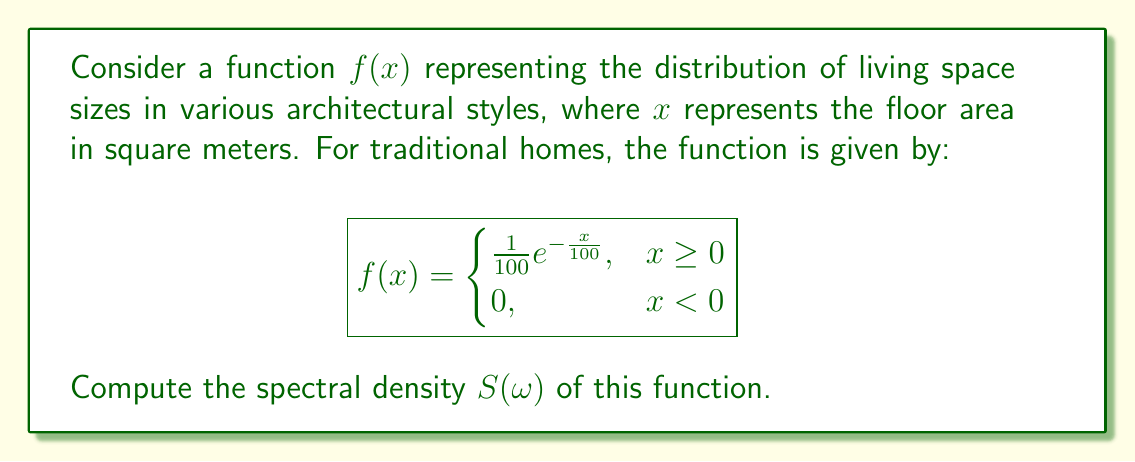Help me with this question. To compute the spectral density, we need to follow these steps:

1) The spectral density is defined as the Fourier transform of the autocorrelation function. First, we need to find the autocorrelation function.

2) The autocorrelation function $R(\tau)$ for a stationary process is:

   $$R(\tau) = \int_{-\infty}^{\infty} f(x)f(x+\tau)dx$$

3) In our case:

   $$R(\tau) = \int_{0}^{\infty} \frac{1}{100}e^{-\frac{x}{100}} \cdot \frac{1}{100}e^{-\frac{x+\tau}{100}}dx$$

4) Simplifying:

   $$R(\tau) = \frac{1}{10000}e^{-\frac{\tau}{100}}\int_{0}^{\infty} e^{-\frac{2x}{100}}dx$$

5) Solving the integral:

   $$R(\tau) = \frac{1}{10000}e^{-\frac{\tau}{100}} \cdot \frac{100}{2} = \frac{1}{200}e^{-\frac{|\tau|}{100}}$$

6) Now, we need to take the Fourier transform of $R(\tau)$ to get $S(\omega)$:

   $$S(\omega) = \int_{-\infty}^{\infty} R(\tau)e^{-i\omega\tau}d\tau$$

7) Substituting our $R(\tau)$:

   $$S(\omega) = \frac{1}{200}\int_{-\infty}^{\infty} e^{-\frac{|\tau|}{100}}e^{-i\omega\tau}d\tau$$

8) This integral can be solved using complex analysis. The result is:

   $$S(\omega) = \frac{1}{200} \cdot \frac{2 \cdot 100}{1 + (100\omega)^2} = \frac{1}{1 + (100\omega)^2}$$

This is the spectral density of the given function.
Answer: $$S(\omega) = \frac{1}{1 + (100\omega)^2}$$ 